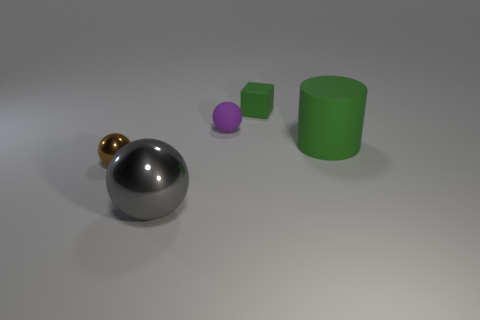Subtract all spheres. How many objects are left? 2 Add 2 gray balls. How many gray balls are left? 3 Add 2 small cyan blocks. How many small cyan blocks exist? 2 Add 5 cubes. How many objects exist? 10 Subtract all brown balls. How many balls are left? 2 Subtract all tiny spheres. How many spheres are left? 1 Subtract 0 purple cylinders. How many objects are left? 5 Subtract 1 cylinders. How many cylinders are left? 0 Subtract all gray spheres. Subtract all gray blocks. How many spheres are left? 2 Subtract all purple cylinders. How many blue cubes are left? 0 